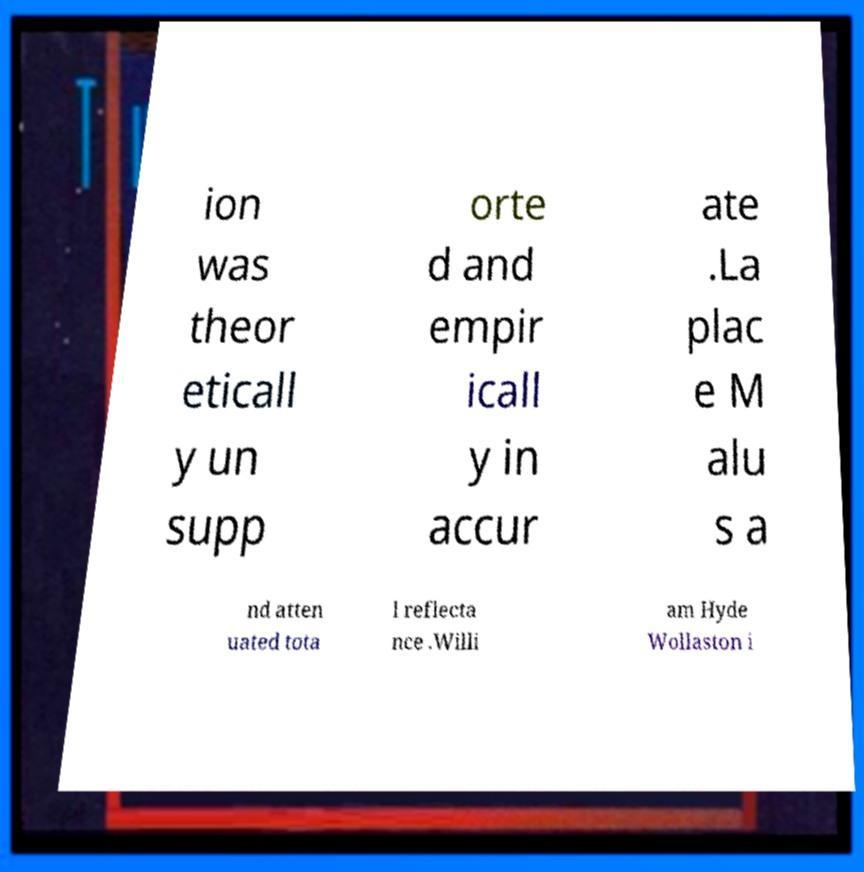For documentation purposes, I need the text within this image transcribed. Could you provide that? ion was theor eticall y un supp orte d and empir icall y in accur ate .La plac e M alu s a nd atten uated tota l reflecta nce .Willi am Hyde Wollaston i 